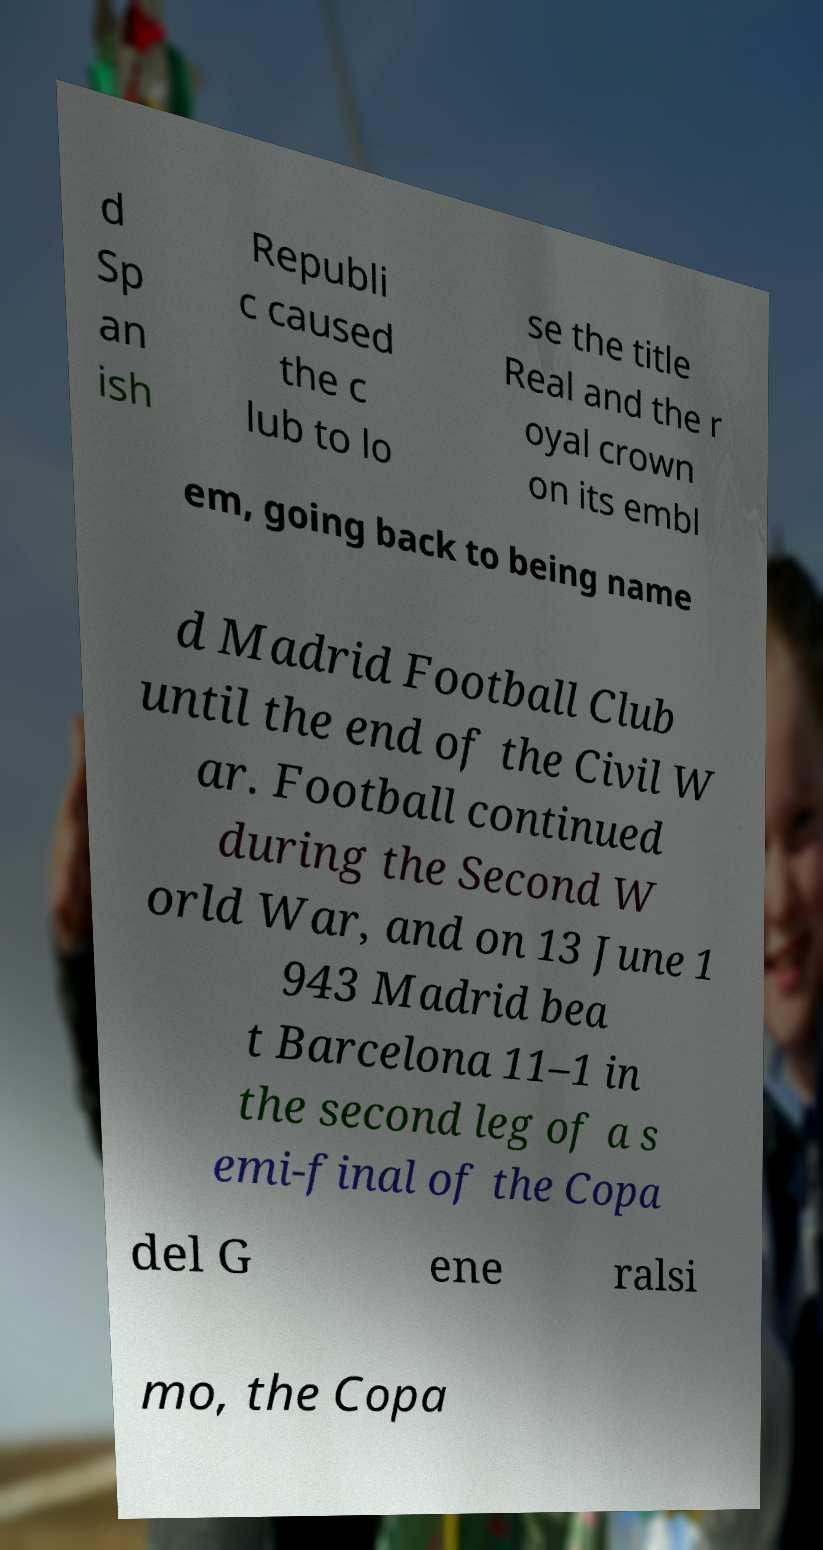Please read and relay the text visible in this image. What does it say? d Sp an ish Republi c caused the c lub to lo se the title Real and the r oyal crown on its embl em, going back to being name d Madrid Football Club until the end of the Civil W ar. Football continued during the Second W orld War, and on 13 June 1 943 Madrid bea t Barcelona 11–1 in the second leg of a s emi-final of the Copa del G ene ralsi mo, the Copa 